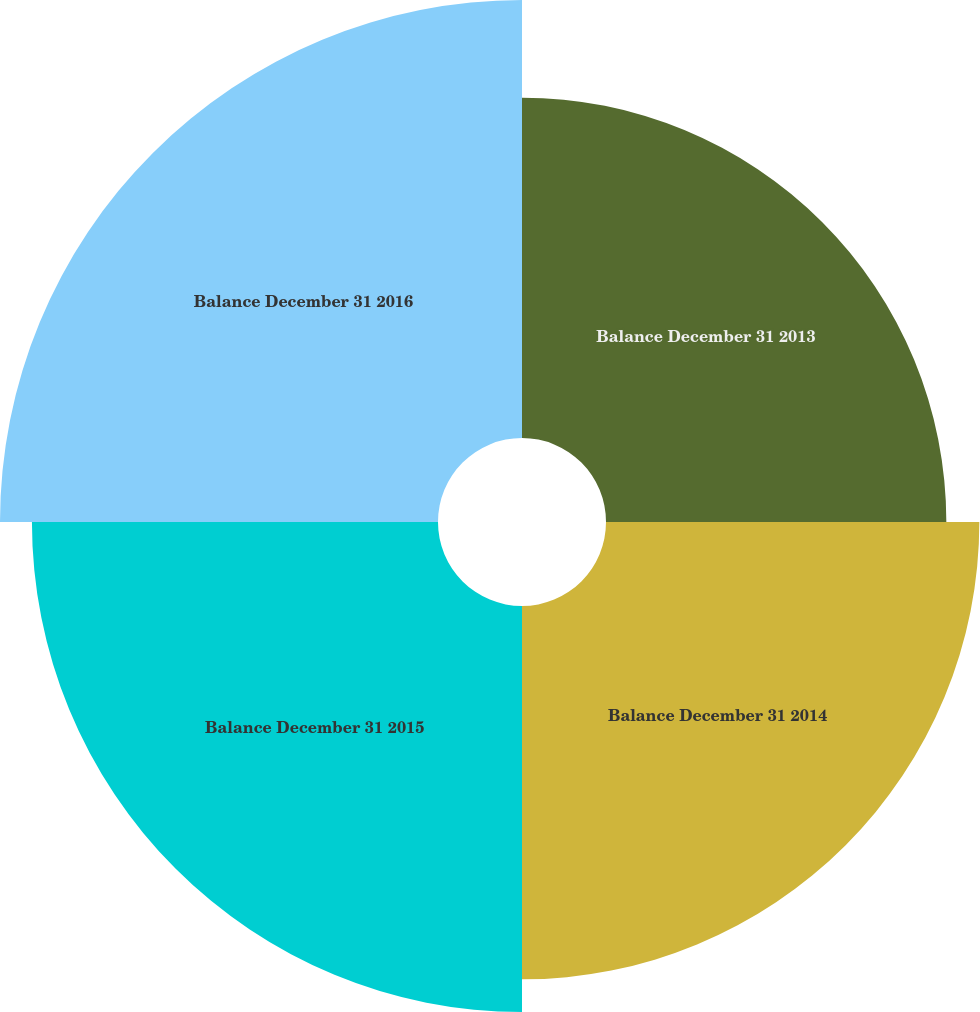Convert chart. <chart><loc_0><loc_0><loc_500><loc_500><pie_chart><fcel>Balance December 31 2013<fcel>Balance December 31 2014<fcel>Balance December 31 2015<fcel>Balance December 31 2016<nl><fcel>21.85%<fcel>23.97%<fcel>26.07%<fcel>28.12%<nl></chart> 